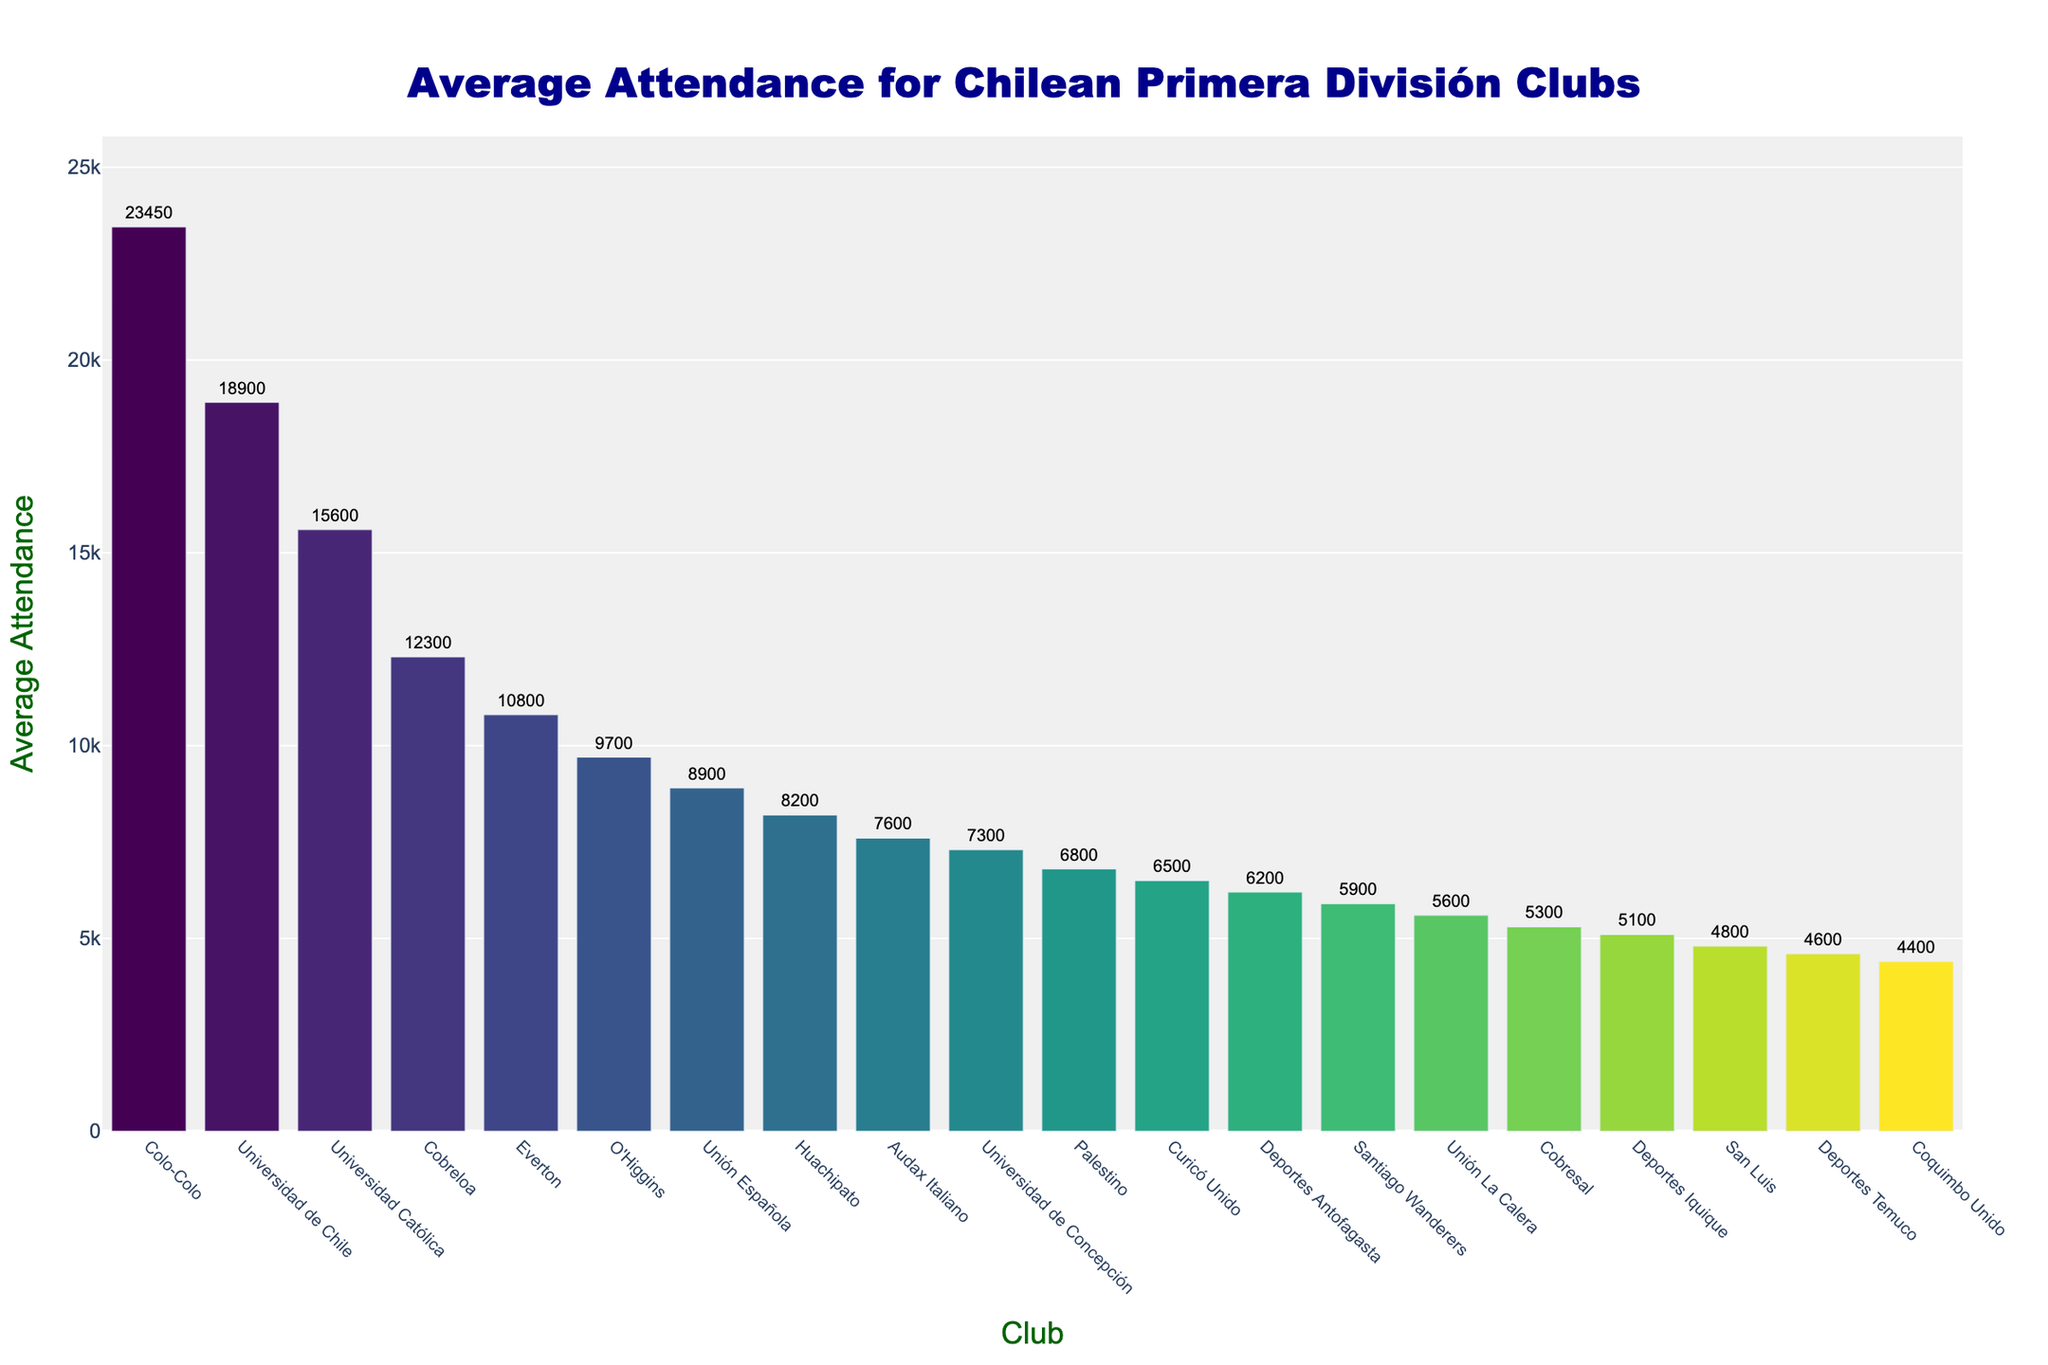What's the highest average attendance for any club? The highest average attendance can be determined by looking at the tallest bar in the chart. Colo-Colo has the tallest bar.
Answer: Colo-Colo Which club has the lowest average attendance? The lowest average attendance can be found by identifying the shortest bar in the chart, which belongs to Coquimbo Unido.
Answer: Coquimbo Unido What's the combined average attendance of the top 3 clubs? The top 3 clubs by average attendance are Colo-Colo, Universidad de Chile, and Universidad Católica. Summing their values: 23450 + 18900 + 15600 = 57950.
Answer: 57950 Are there any clubs with average attendance between 7,000 and 9,000? By scanning the bars visually, clubs within this range are Universidad de Concepción, Palestino, and Huachipato.
Answer: Yes How many clubs have an average attendance above 10,000? By counting the bars extending above 10,000, we find the clubs: Colo-Colo, Universidad de Chile, Universidad Católica, Cobreloa, and Everton.
Answer: 5 Which club has the highest average attendance among the clubs with names starting with "U"? Considering clubs Universidad de Chile, Universidad Católica, and Universidad de Concepción, Universidad de Chile has the highest bar among them.
Answer: Universidad de Chile What's the average attendance of Unión Española compared to O'Higgins? Unión Española has an attendance of 8900, and O'Higgins has 9700. 9700 is higher than 8900.
Answer: O'Higgins has higher attendance What's the difference in average attendance between Cobresal and Deportes Temuco? Cobresal has an average attendance of 5300, and Deportes Temuco has 4600. The difference is 5300 - 4600 = 700.
Answer: 700 How does Audax Italiano's attendance compare to Unión La Calera's? Audax Italiano's average attendance is 7600, while Unión La Calera's is 5600. Audax Italiano's attendance is higher.
Answer: Audax Italiano has higher attendance What's the total average attendance of all clubs with more than 20,000 average attendance? Only Colo-Colo with 23450 fits this criterion. Hence, the total is 23450.
Answer: 23450 Which color represents Palestino in the chart? By visually identifying the bar corresponding to Palestino and noting its color from the chart, we find it is greenish (using the Viridis colorscale).
Answer: Greenish 